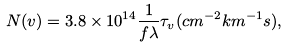<formula> <loc_0><loc_0><loc_500><loc_500>N ( v ) = 3 . 8 \times 1 0 ^ { 1 4 } \frac { 1 } { f \lambda } \tau _ { v } ( c m ^ { - 2 } k m ^ { - 1 } s ) ,</formula> 